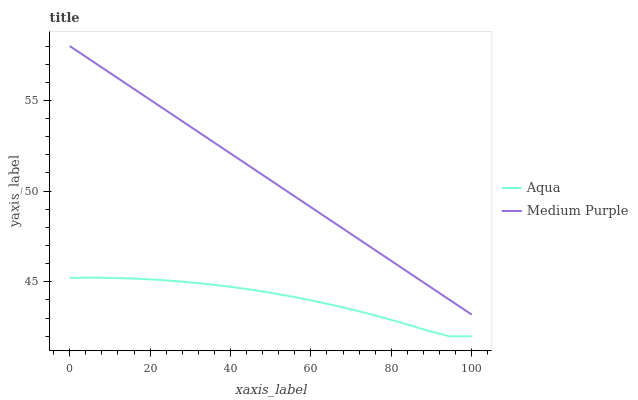Does Aqua have the minimum area under the curve?
Answer yes or no. Yes. Does Medium Purple have the maximum area under the curve?
Answer yes or no. Yes. Does Aqua have the maximum area under the curve?
Answer yes or no. No. Is Medium Purple the smoothest?
Answer yes or no. Yes. Is Aqua the roughest?
Answer yes or no. Yes. Is Aqua the smoothest?
Answer yes or no. No. Does Aqua have the highest value?
Answer yes or no. No. Is Aqua less than Medium Purple?
Answer yes or no. Yes. Is Medium Purple greater than Aqua?
Answer yes or no. Yes. Does Aqua intersect Medium Purple?
Answer yes or no. No. 